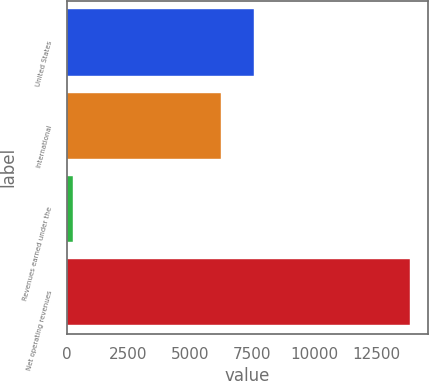<chart> <loc_0><loc_0><loc_500><loc_500><bar_chart><fcel>United States<fcel>International<fcel>Revenues earned under the<fcel>Net operating revenues<nl><fcel>7581.5<fcel>6219<fcel>255<fcel>13880<nl></chart> 